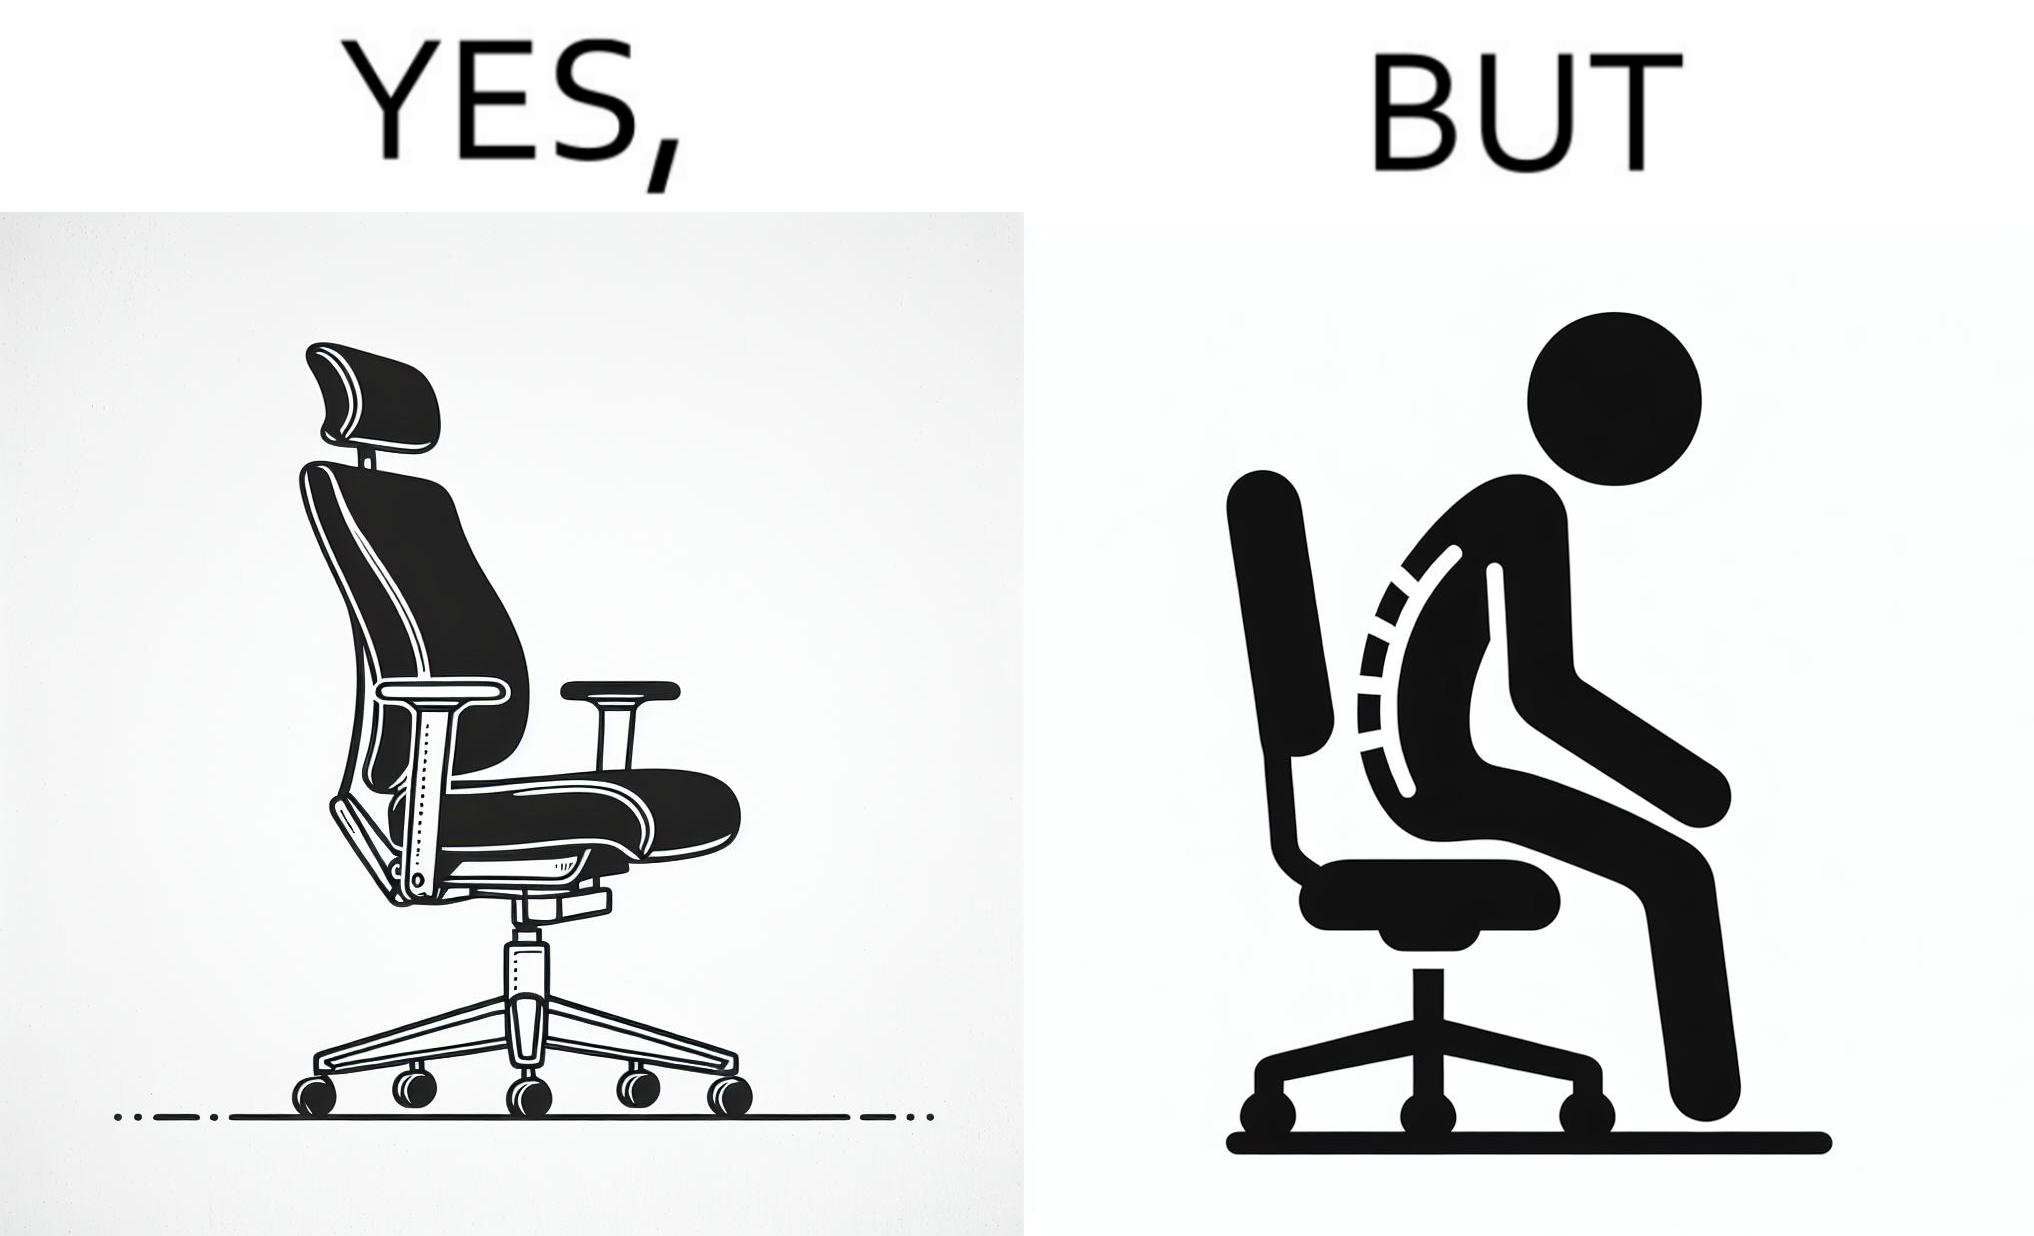What is the satirical meaning behind this image? The image is ironical, as even though the ergonomic chair is meant to facilitate an upright and comfortable posture for the person sitting on it, the person sitting on it still has a bent posture, as the person is not utilizing the backrest. 